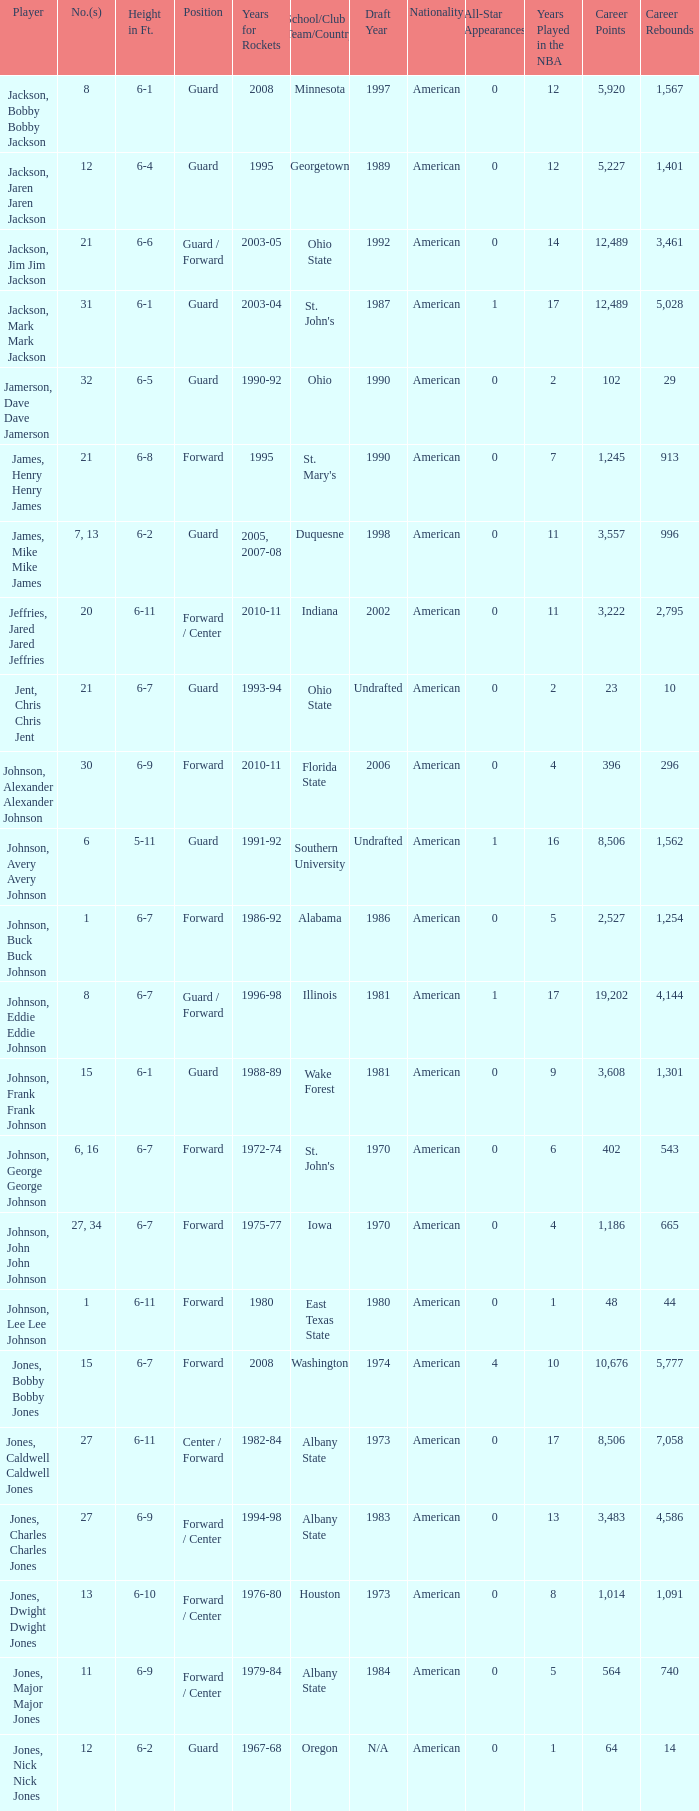What's the stature of the player jones, major major jones? 6-9. 